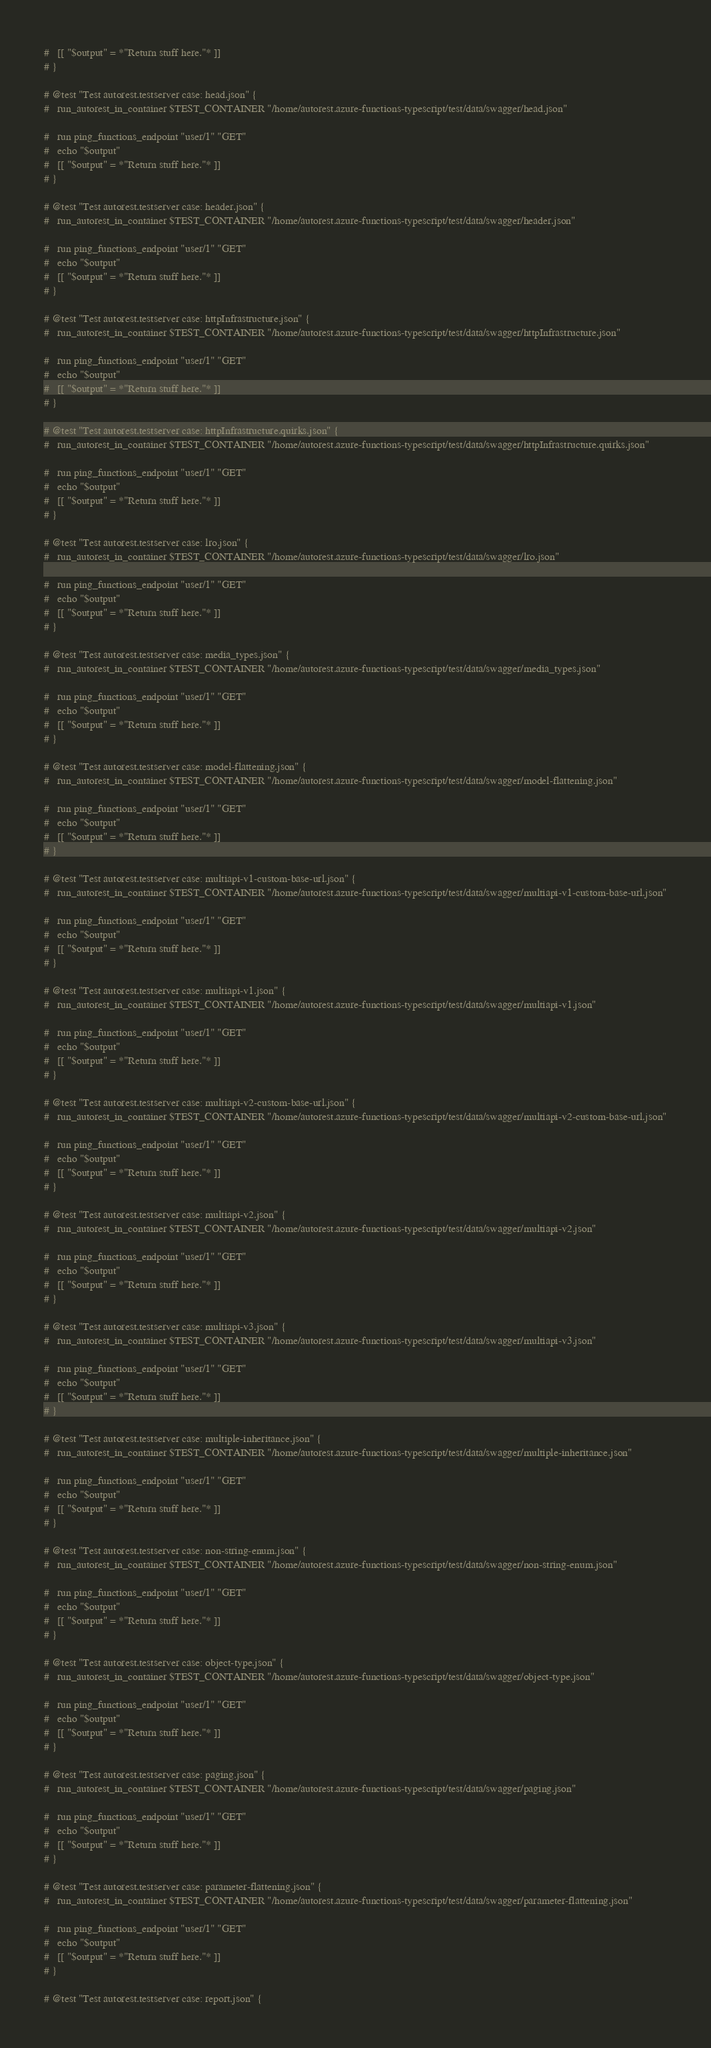Convert code to text. <code><loc_0><loc_0><loc_500><loc_500><_Bash_>#   [[ "$output" = *"Return stuff here."* ]]
# }

# @test "Test autorest.testserver case: head.json" {
#   run_autorest_in_container $TEST_CONTAINER "/home/autorest.azure-functions-typescript/test/data/swagger/head.json"
  
#   run ping_functions_endpoint "user/1" "GET"
#   echo "$output"
#   [[ "$output" = *"Return stuff here."* ]]
# }

# @test "Test autorest.testserver case: header.json" {
#   run_autorest_in_container $TEST_CONTAINER "/home/autorest.azure-functions-typescript/test/data/swagger/header.json"
  
#   run ping_functions_endpoint "user/1" "GET"
#   echo "$output"
#   [[ "$output" = *"Return stuff here."* ]]
# }

# @test "Test autorest.testserver case: httpInfrastructure.json" {
#   run_autorest_in_container $TEST_CONTAINER "/home/autorest.azure-functions-typescript/test/data/swagger/httpInfrastructure.json"
  
#   run ping_functions_endpoint "user/1" "GET"
#   echo "$output"
#   [[ "$output" = *"Return stuff here."* ]]
# }

# @test "Test autorest.testserver case: httpInfrastructure.quirks.json" {
#   run_autorest_in_container $TEST_CONTAINER "/home/autorest.azure-functions-typescript/test/data/swagger/httpInfrastructure.quirks.json"
  
#   run ping_functions_endpoint "user/1" "GET"
#   echo "$output"
#   [[ "$output" = *"Return stuff here."* ]]
# }

# @test "Test autorest.testserver case: lro.json" {
#   run_autorest_in_container $TEST_CONTAINER "/home/autorest.azure-functions-typescript/test/data/swagger/lro.json"
  
#   run ping_functions_endpoint "user/1" "GET"
#   echo "$output"
#   [[ "$output" = *"Return stuff here."* ]]
# }

# @test "Test autorest.testserver case: media_types.json" {
#   run_autorest_in_container $TEST_CONTAINER "/home/autorest.azure-functions-typescript/test/data/swagger/media_types.json"
  
#   run ping_functions_endpoint "user/1" "GET"
#   echo "$output"
#   [[ "$output" = *"Return stuff here."* ]]
# }

# @test "Test autorest.testserver case: model-flattening.json" {
#   run_autorest_in_container $TEST_CONTAINER "/home/autorest.azure-functions-typescript/test/data/swagger/model-flattening.json"
  
#   run ping_functions_endpoint "user/1" "GET"
#   echo "$output"
#   [[ "$output" = *"Return stuff here."* ]]
# }

# @test "Test autorest.testserver case: multiapi-v1-custom-base-url.json" {
#   run_autorest_in_container $TEST_CONTAINER "/home/autorest.azure-functions-typescript/test/data/swagger/multiapi-v1-custom-base-url.json"
  
#   run ping_functions_endpoint "user/1" "GET"
#   echo "$output"
#   [[ "$output" = *"Return stuff here."* ]]
# }

# @test "Test autorest.testserver case: multiapi-v1.json" {
#   run_autorest_in_container $TEST_CONTAINER "/home/autorest.azure-functions-typescript/test/data/swagger/multiapi-v1.json"
  
#   run ping_functions_endpoint "user/1" "GET"
#   echo "$output"
#   [[ "$output" = *"Return stuff here."* ]]
# }

# @test "Test autorest.testserver case: multiapi-v2-custom-base-url.json" {
#   run_autorest_in_container $TEST_CONTAINER "/home/autorest.azure-functions-typescript/test/data/swagger/multiapi-v2-custom-base-url.json"
  
#   run ping_functions_endpoint "user/1" "GET"
#   echo "$output"
#   [[ "$output" = *"Return stuff here."* ]]
# }

# @test "Test autorest.testserver case: multiapi-v2.json" {
#   run_autorest_in_container $TEST_CONTAINER "/home/autorest.azure-functions-typescript/test/data/swagger/multiapi-v2.json"
  
#   run ping_functions_endpoint "user/1" "GET"
#   echo "$output"
#   [[ "$output" = *"Return stuff here."* ]]
# }

# @test "Test autorest.testserver case: multiapi-v3.json" {
#   run_autorest_in_container $TEST_CONTAINER "/home/autorest.azure-functions-typescript/test/data/swagger/multiapi-v3.json"
  
#   run ping_functions_endpoint "user/1" "GET"
#   echo "$output"
#   [[ "$output" = *"Return stuff here."* ]]
# }

# @test "Test autorest.testserver case: multiple-inheritance.json" {
#   run_autorest_in_container $TEST_CONTAINER "/home/autorest.azure-functions-typescript/test/data/swagger/multiple-inheritance.json"
  
#   run ping_functions_endpoint "user/1" "GET"
#   echo "$output"
#   [[ "$output" = *"Return stuff here."* ]]
# }

# @test "Test autorest.testserver case: non-string-enum.json" {
#   run_autorest_in_container $TEST_CONTAINER "/home/autorest.azure-functions-typescript/test/data/swagger/non-string-enum.json"
  
#   run ping_functions_endpoint "user/1" "GET"
#   echo "$output"
#   [[ "$output" = *"Return stuff here."* ]]
# }

# @test "Test autorest.testserver case: object-type.json" {
#   run_autorest_in_container $TEST_CONTAINER "/home/autorest.azure-functions-typescript/test/data/swagger/object-type.json"
  
#   run ping_functions_endpoint "user/1" "GET"
#   echo "$output"
#   [[ "$output" = *"Return stuff here."* ]]
# }

# @test "Test autorest.testserver case: paging.json" {
#   run_autorest_in_container $TEST_CONTAINER "/home/autorest.azure-functions-typescript/test/data/swagger/paging.json"
  
#   run ping_functions_endpoint "user/1" "GET"
#   echo "$output"
#   [[ "$output" = *"Return stuff here."* ]]
# }

# @test "Test autorest.testserver case: parameter-flattening.json" {
#   run_autorest_in_container $TEST_CONTAINER "/home/autorest.azure-functions-typescript/test/data/swagger/parameter-flattening.json"
  
#   run ping_functions_endpoint "user/1" "GET"
#   echo "$output"
#   [[ "$output" = *"Return stuff here."* ]]
# }

# @test "Test autorest.testserver case: report.json" {</code> 